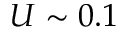Convert formula to latex. <formula><loc_0><loc_0><loc_500><loc_500>U \sim 0 . 1</formula> 